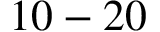<formula> <loc_0><loc_0><loc_500><loc_500>1 0 - 2 0</formula> 